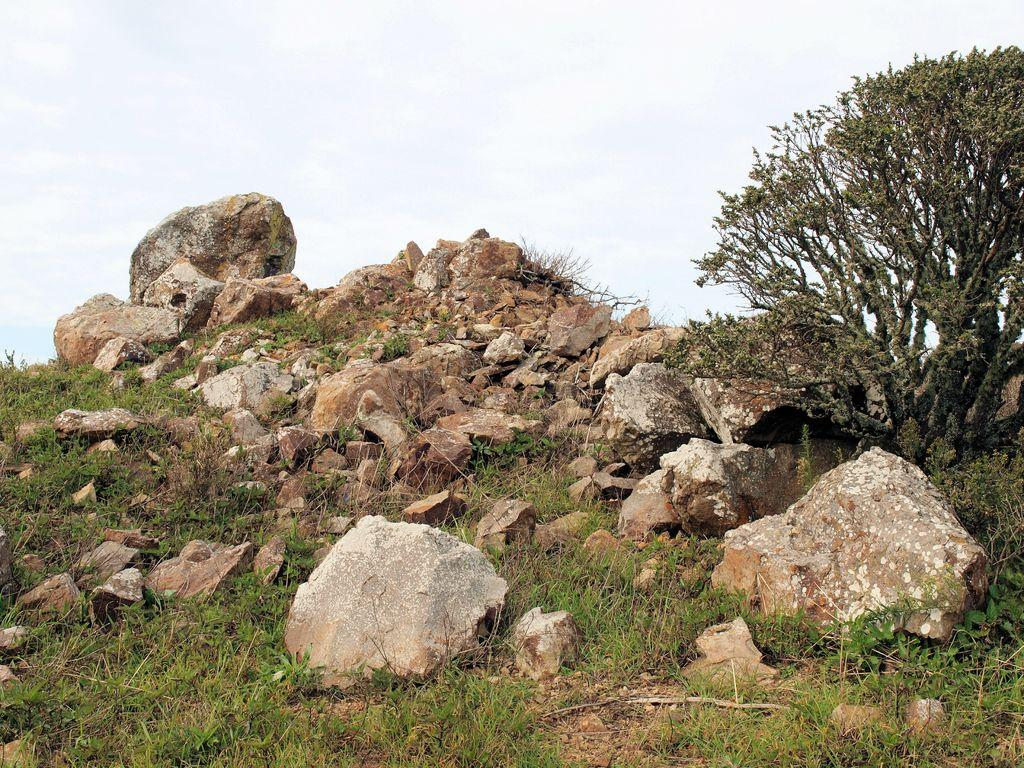What type of natural elements can be seen in the image? There are rocks, grass, and plants visible in the image. What part of the natural environment is visible in the image? The sky is visible in the image. Can you describe the vegetation present in the image? There are plants and grass visible in the image. Can you tell me how many tigers are walking through the grass in the image? There are no tigers present in the image; it features rocks, grass, plants, and the sky. How does the grass get washed in the image? There is no indication of the grass being washed in the image; it is simply a natural element present in the scene. 